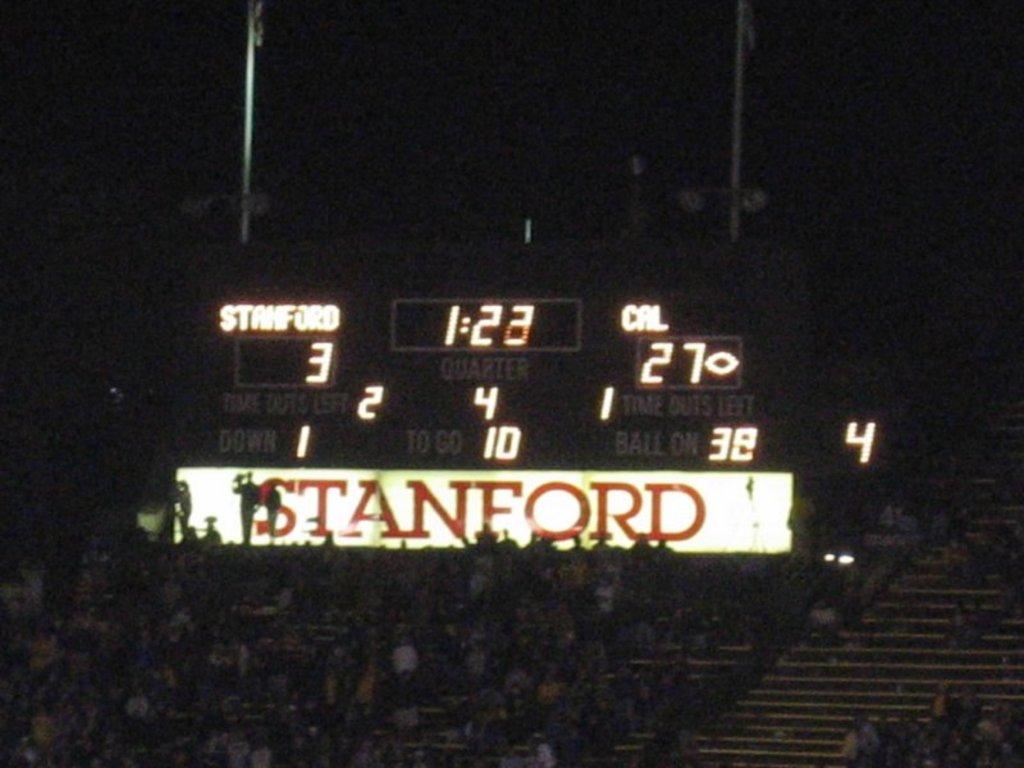How many points does stanford have?
Provide a succinct answer. 3. What university is written in huge letters below the scoreboard?
Your answer should be compact. Stanford. 